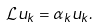<formula> <loc_0><loc_0><loc_500><loc_500>\mathcal { L } u _ { k } = \alpha _ { k } u _ { k } .</formula> 